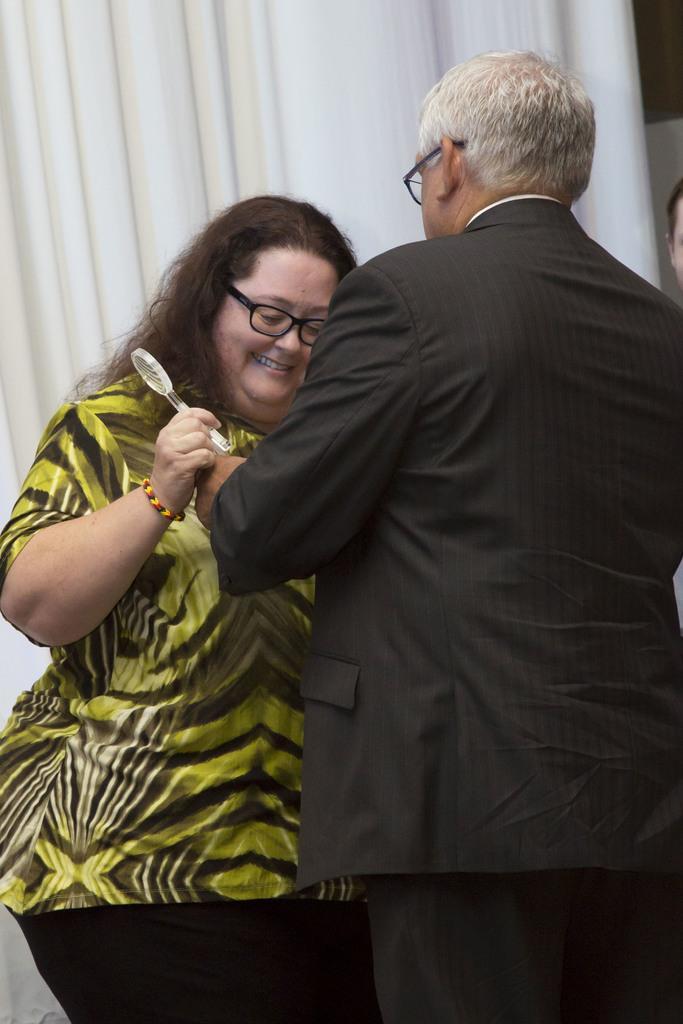Could you give a brief overview of what you see in this image? As we can see in the image there are two people and white color curtain. The woman over here is wearing green color dress. 